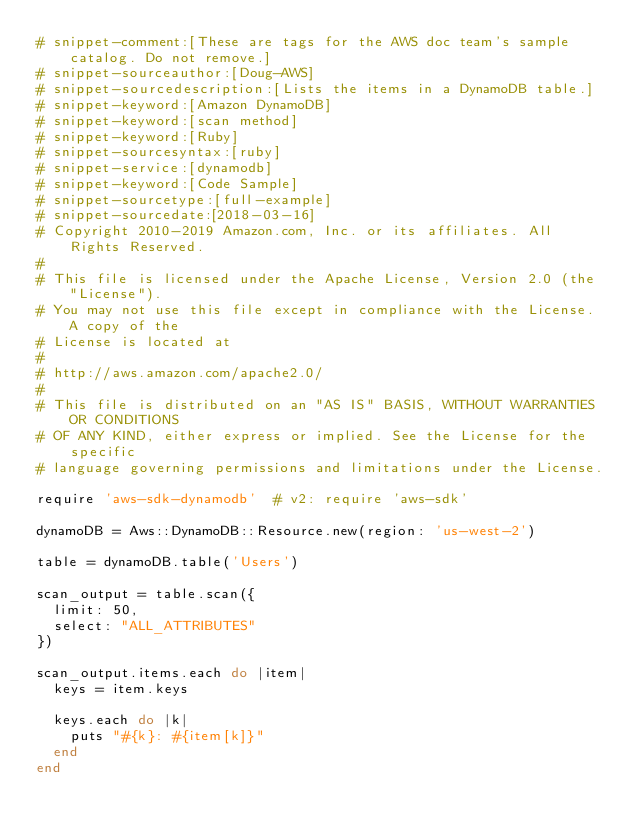<code> <loc_0><loc_0><loc_500><loc_500><_Ruby_># snippet-comment:[These are tags for the AWS doc team's sample catalog. Do not remove.]
# snippet-sourceauthor:[Doug-AWS]
# snippet-sourcedescription:[Lists the items in a DynamoDB table.]
# snippet-keyword:[Amazon DynamoDB]
# snippet-keyword:[scan method]
# snippet-keyword:[Ruby]
# snippet-sourcesyntax:[ruby]
# snippet-service:[dynamodb]
# snippet-keyword:[Code Sample]
# snippet-sourcetype:[full-example]
# snippet-sourcedate:[2018-03-16]
# Copyright 2010-2019 Amazon.com, Inc. or its affiliates. All Rights Reserved.
#
# This file is licensed under the Apache License, Version 2.0 (the "License").
# You may not use this file except in compliance with the License. A copy of the
# License is located at
#
# http://aws.amazon.com/apache2.0/
#
# This file is distributed on an "AS IS" BASIS, WITHOUT WARRANTIES OR CONDITIONS
# OF ANY KIND, either express or implied. See the License for the specific
# language governing permissions and limitations under the License.

require 'aws-sdk-dynamodb'  # v2: require 'aws-sdk'

dynamoDB = Aws::DynamoDB::Resource.new(region: 'us-west-2')

table = dynamoDB.table('Users')

scan_output = table.scan({
  limit: 50,
  select: "ALL_ATTRIBUTES"
})

scan_output.items.each do |item|
  keys = item.keys

  keys.each do |k|
    puts "#{k}: #{item[k]}"
  end
end
</code> 